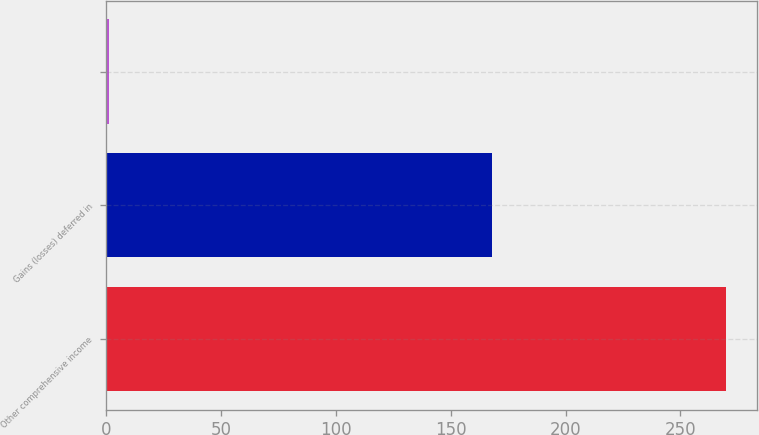Convert chart to OTSL. <chart><loc_0><loc_0><loc_500><loc_500><bar_chart><fcel>Other comprehensive income<fcel>Gains (losses) deferred in<fcel>Unnamed: 2<nl><fcel>270<fcel>168<fcel>1<nl></chart> 